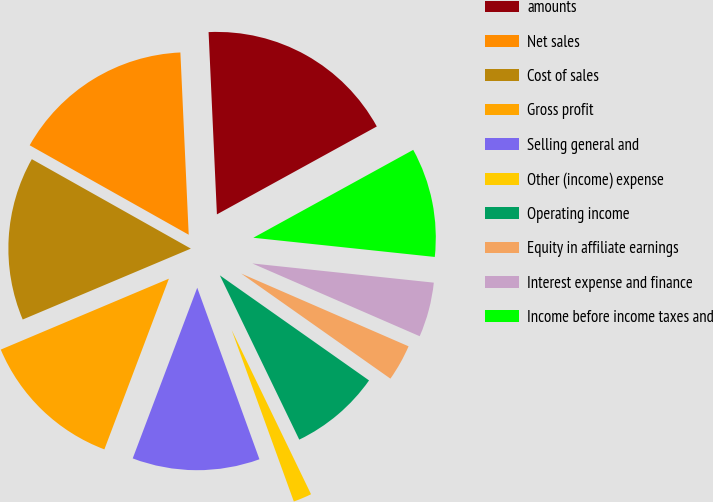Convert chart to OTSL. <chart><loc_0><loc_0><loc_500><loc_500><pie_chart><fcel>amounts<fcel>Net sales<fcel>Cost of sales<fcel>Gross profit<fcel>Selling general and<fcel>Other (income) expense<fcel>Operating income<fcel>Equity in affiliate earnings<fcel>Interest expense and finance<fcel>Income before income taxes and<nl><fcel>17.73%<fcel>16.12%<fcel>14.51%<fcel>12.9%<fcel>11.29%<fcel>1.63%<fcel>8.07%<fcel>3.24%<fcel>4.85%<fcel>9.68%<nl></chart> 